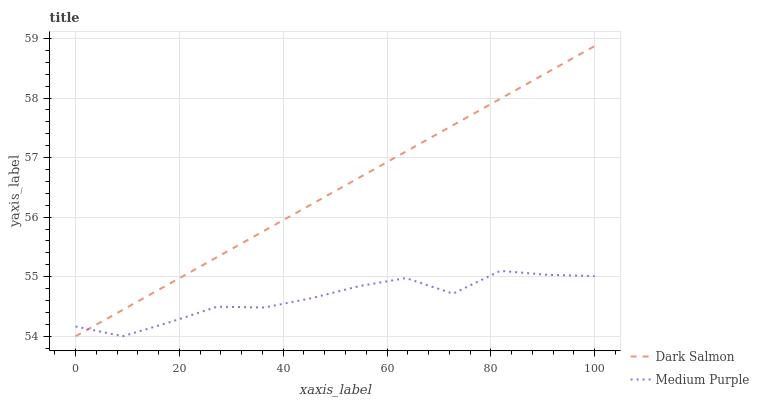Does Medium Purple have the minimum area under the curve?
Answer yes or no. Yes. Does Dark Salmon have the maximum area under the curve?
Answer yes or no. Yes. Does Dark Salmon have the minimum area under the curve?
Answer yes or no. No. Is Dark Salmon the smoothest?
Answer yes or no. Yes. Is Medium Purple the roughest?
Answer yes or no. Yes. Is Dark Salmon the roughest?
Answer yes or no. No. Does Medium Purple have the lowest value?
Answer yes or no. Yes. Does Dark Salmon have the highest value?
Answer yes or no. Yes. Does Dark Salmon intersect Medium Purple?
Answer yes or no. Yes. Is Dark Salmon less than Medium Purple?
Answer yes or no. No. Is Dark Salmon greater than Medium Purple?
Answer yes or no. No. 